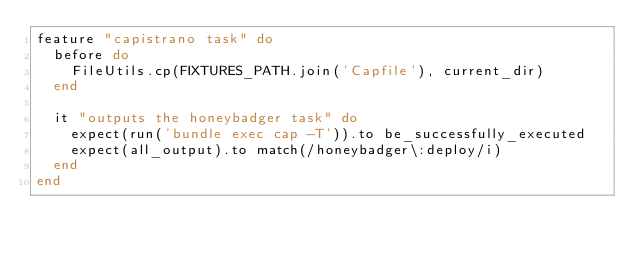<code> <loc_0><loc_0><loc_500><loc_500><_Ruby_>feature "capistrano task" do
  before do
    FileUtils.cp(FIXTURES_PATH.join('Capfile'), current_dir)
  end

  it "outputs the honeybadger task" do
    expect(run('bundle exec cap -T')).to be_successfully_executed
    expect(all_output).to match(/honeybadger\:deploy/i)
  end
end
</code> 